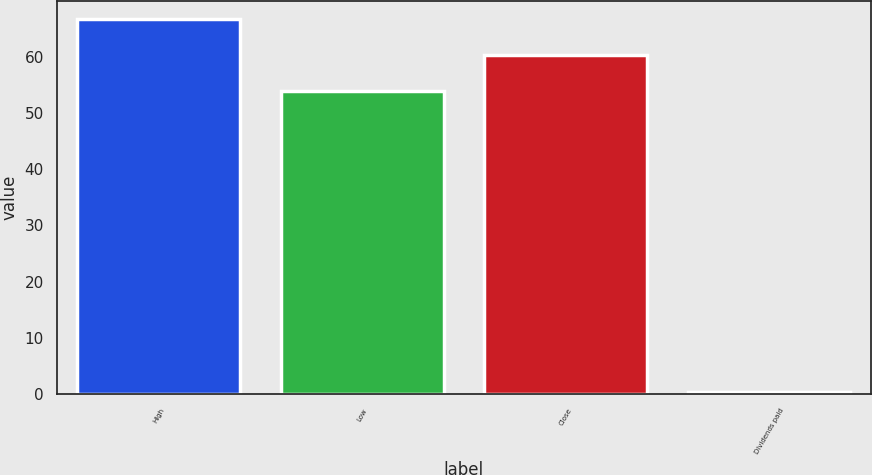<chart> <loc_0><loc_0><loc_500><loc_500><bar_chart><fcel>High<fcel>Low<fcel>Close<fcel>Dividends paid<nl><fcel>66.61<fcel>53.8<fcel>60.2<fcel>0.34<nl></chart> 